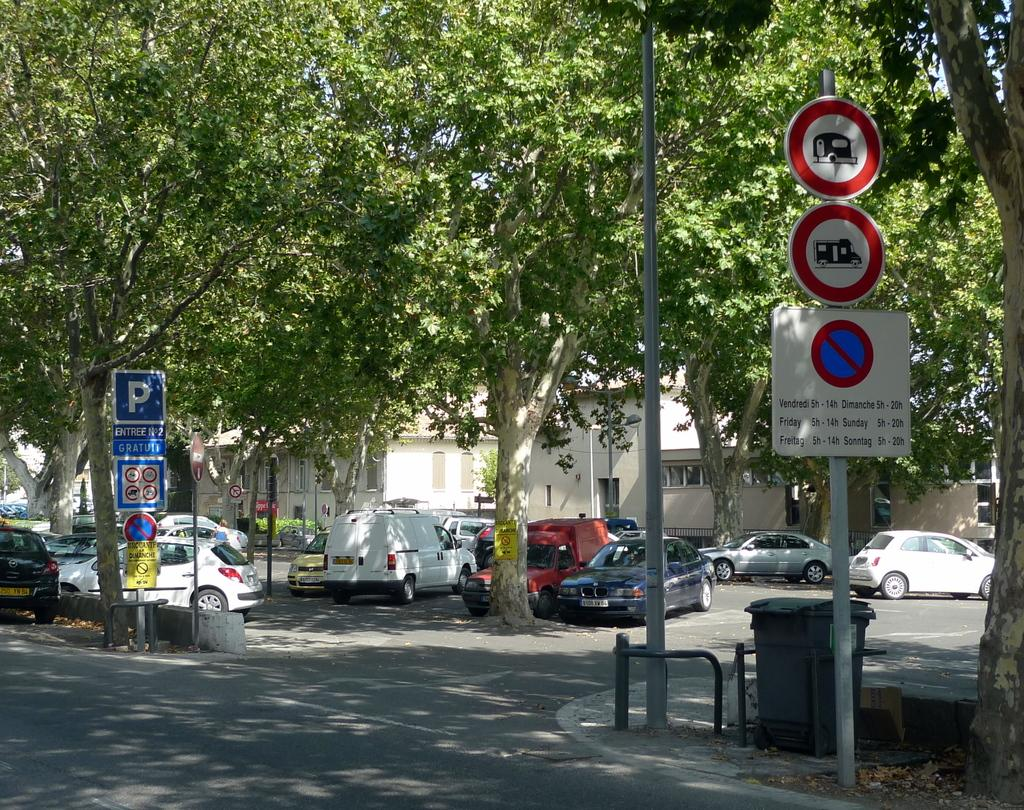<image>
Share a concise interpretation of the image provided. A street with some trees showing various parking signs in French which include no parking vendredi 5h - 14h. 